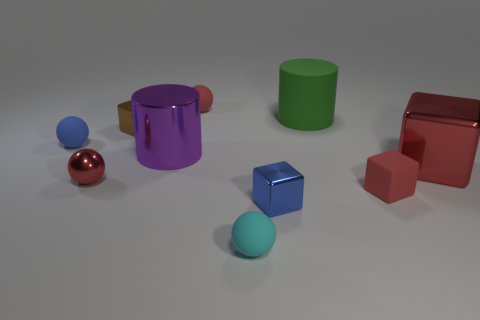Subtract all purple cubes. Subtract all yellow cylinders. How many cubes are left? 4 Subtract all cubes. How many objects are left? 6 Add 9 big rubber cylinders. How many big rubber cylinders exist? 10 Subtract 1 green cylinders. How many objects are left? 9 Subtract all red rubber cubes. Subtract all green matte objects. How many objects are left? 8 Add 2 red metal blocks. How many red metal blocks are left? 3 